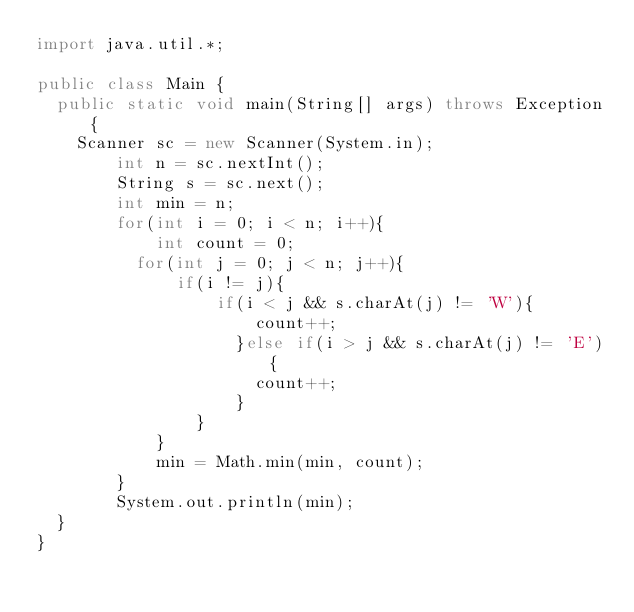<code> <loc_0><loc_0><loc_500><loc_500><_Java_>import java.util.*;
 
public class Main {
	public static void main(String[] args) throws Exception{
		Scanner sc = new Scanner(System.in);
        int n = sc.nextInt();
        String s = sc.next();
        int min = n;
        for(int i = 0; i < n; i++){
            int count = 0;
        	for(int j = 0; j < n; j++){
            	if(i != j){
                	if(i < j && s.charAt(j) != 'W'){
                    	count++;
                    }else if(i > j && s.charAt(j) != 'E'){
                    	count++;
                    }
                }
            }
            min = Math.min(min, count);
        }
        System.out.println(min);
	}
}</code> 